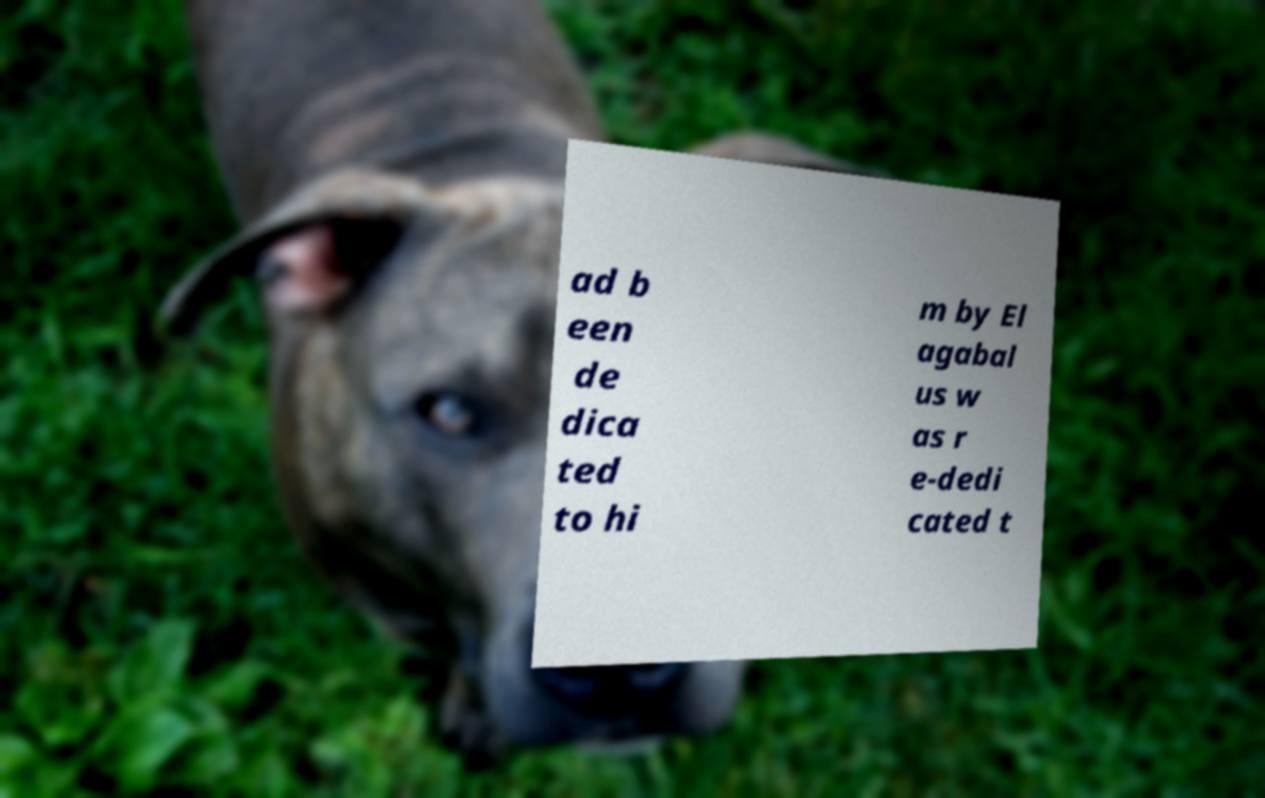Could you extract and type out the text from this image? ad b een de dica ted to hi m by El agabal us w as r e-dedi cated t 